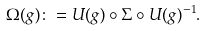Convert formula to latex. <formula><loc_0><loc_0><loc_500><loc_500>\Omega ( g ) \colon = U ( g ) \circ \Sigma \circ U ( g ) ^ { - 1 } .</formula> 